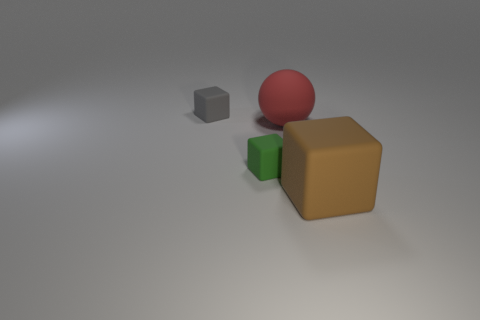Subtract all tiny blocks. How many blocks are left? 1 Add 1 large red spheres. How many objects exist? 5 Subtract all gray blocks. How many blocks are left? 2 Add 4 small green rubber objects. How many small green rubber objects are left? 5 Add 3 small matte things. How many small matte things exist? 5 Subtract 1 brown cubes. How many objects are left? 3 Subtract all cubes. How many objects are left? 1 Subtract 1 cubes. How many cubes are left? 2 Subtract all red blocks. Subtract all blue cylinders. How many blocks are left? 3 Subtract all blue spheres. How many gray blocks are left? 1 